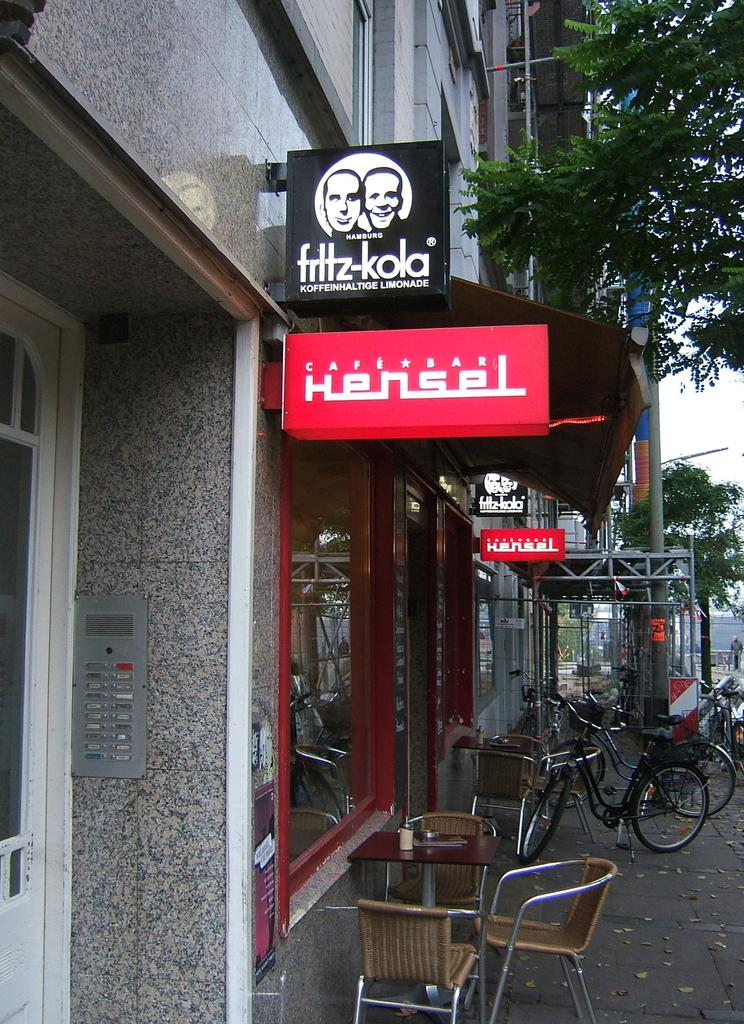What type of structure can be seen in the image? There is a building in the image. What is present on the building in the image? There is a hoarding and a name board on the building in the image. What type of furniture is visible in the image? There is a table and a chair in the image. What mode of transportation can be seen in the image? There is a bicycle in the image. What type of plant is present in the image? There is a tree in the image. What part of the natural environment is visible in the image? The sky is visible in the image. What other object can be seen in the image? There is a pole in the image. Can you see a record being played on the table in the image? There is no record or any indication of music playing in the image. Is there a sea visible in the image? No, there is no sea present in the image; only a building, a tree, and the sky are visible. 